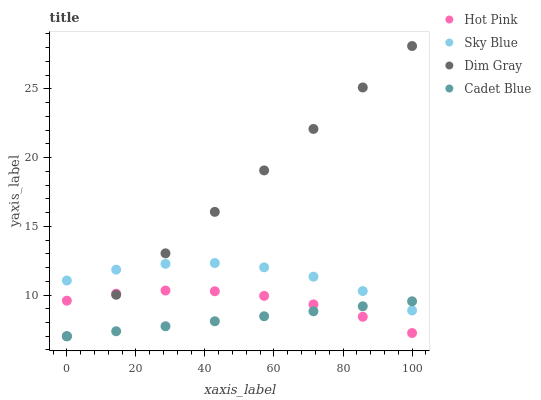Does Cadet Blue have the minimum area under the curve?
Answer yes or no. Yes. Does Dim Gray have the maximum area under the curve?
Answer yes or no. Yes. Does Sky Blue have the minimum area under the curve?
Answer yes or no. No. Does Sky Blue have the maximum area under the curve?
Answer yes or no. No. Is Cadet Blue the smoothest?
Answer yes or no. Yes. Is Sky Blue the roughest?
Answer yes or no. Yes. Is Dim Gray the smoothest?
Answer yes or no. No. Is Dim Gray the roughest?
Answer yes or no. No. Does Cadet Blue have the lowest value?
Answer yes or no. Yes. Does Sky Blue have the lowest value?
Answer yes or no. No. Does Dim Gray have the highest value?
Answer yes or no. Yes. Does Sky Blue have the highest value?
Answer yes or no. No. Is Hot Pink less than Sky Blue?
Answer yes or no. Yes. Is Sky Blue greater than Hot Pink?
Answer yes or no. Yes. Does Dim Gray intersect Sky Blue?
Answer yes or no. Yes. Is Dim Gray less than Sky Blue?
Answer yes or no. No. Is Dim Gray greater than Sky Blue?
Answer yes or no. No. Does Hot Pink intersect Sky Blue?
Answer yes or no. No. 